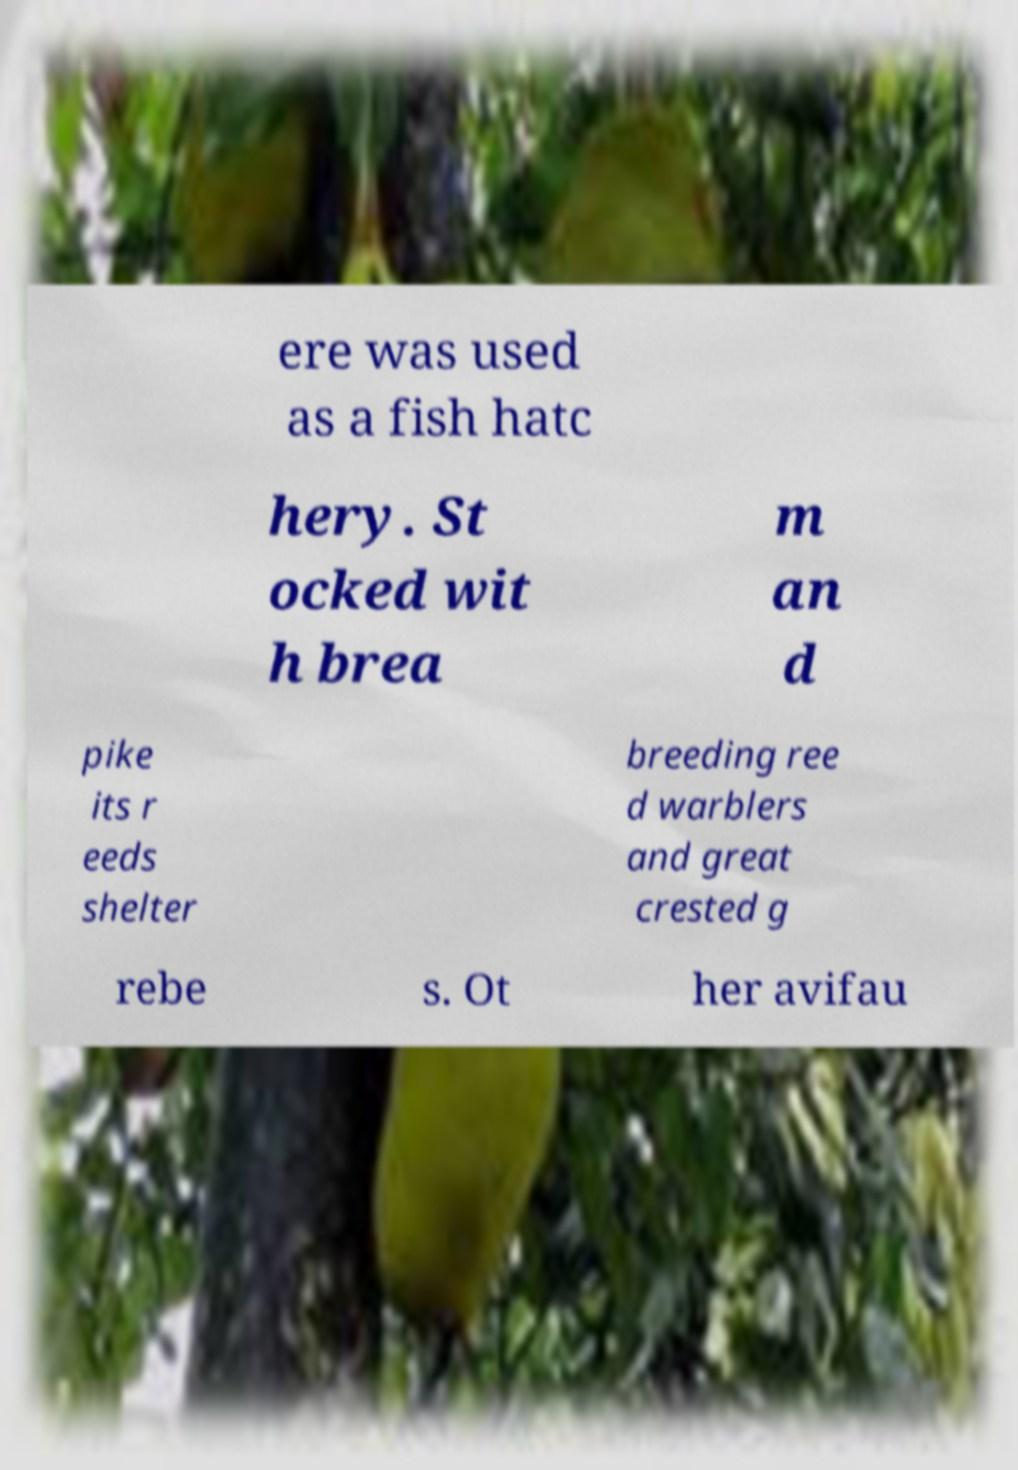Please identify and transcribe the text found in this image. ere was used as a fish hatc hery. St ocked wit h brea m an d pike its r eeds shelter breeding ree d warblers and great crested g rebe s. Ot her avifau 